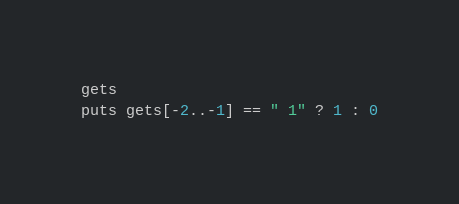<code> <loc_0><loc_0><loc_500><loc_500><_Ruby_>gets
puts gets[-2..-1] == " 1" ? 1 : 0</code> 